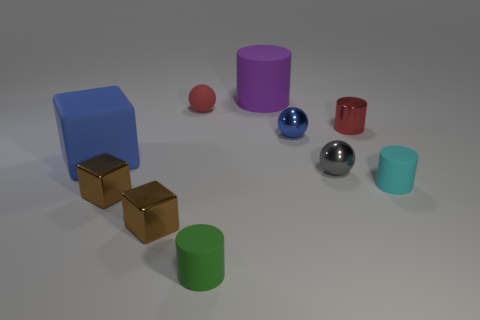Is the number of small gray things on the right side of the red cylinder less than the number of large rubber objects?
Your answer should be compact. Yes. Is there a big thing behind the red metal cylinder that is on the right side of the small red rubber ball?
Your response must be concise. Yes. Is the rubber sphere the same size as the matte block?
Keep it short and to the point. No. There is a red object that is on the left side of the small cylinder that is left of the blue thing that is behind the rubber cube; what is it made of?
Offer a very short reply. Rubber. Are there the same number of small blue spheres right of the blue metallic object and large cyan cubes?
Offer a very short reply. Yes. What number of objects are green rubber cylinders or small yellow spheres?
Your response must be concise. 1. What is the shape of the red thing that is the same material as the green thing?
Provide a short and direct response. Sphere. There is a ball that is on the left side of the tiny cylinder that is to the left of the metallic cylinder; what size is it?
Offer a very short reply. Small. How many tiny objects are gray objects or brown metal objects?
Make the answer very short. 3. How many other things are there of the same color as the matte ball?
Your answer should be very brief. 1. 